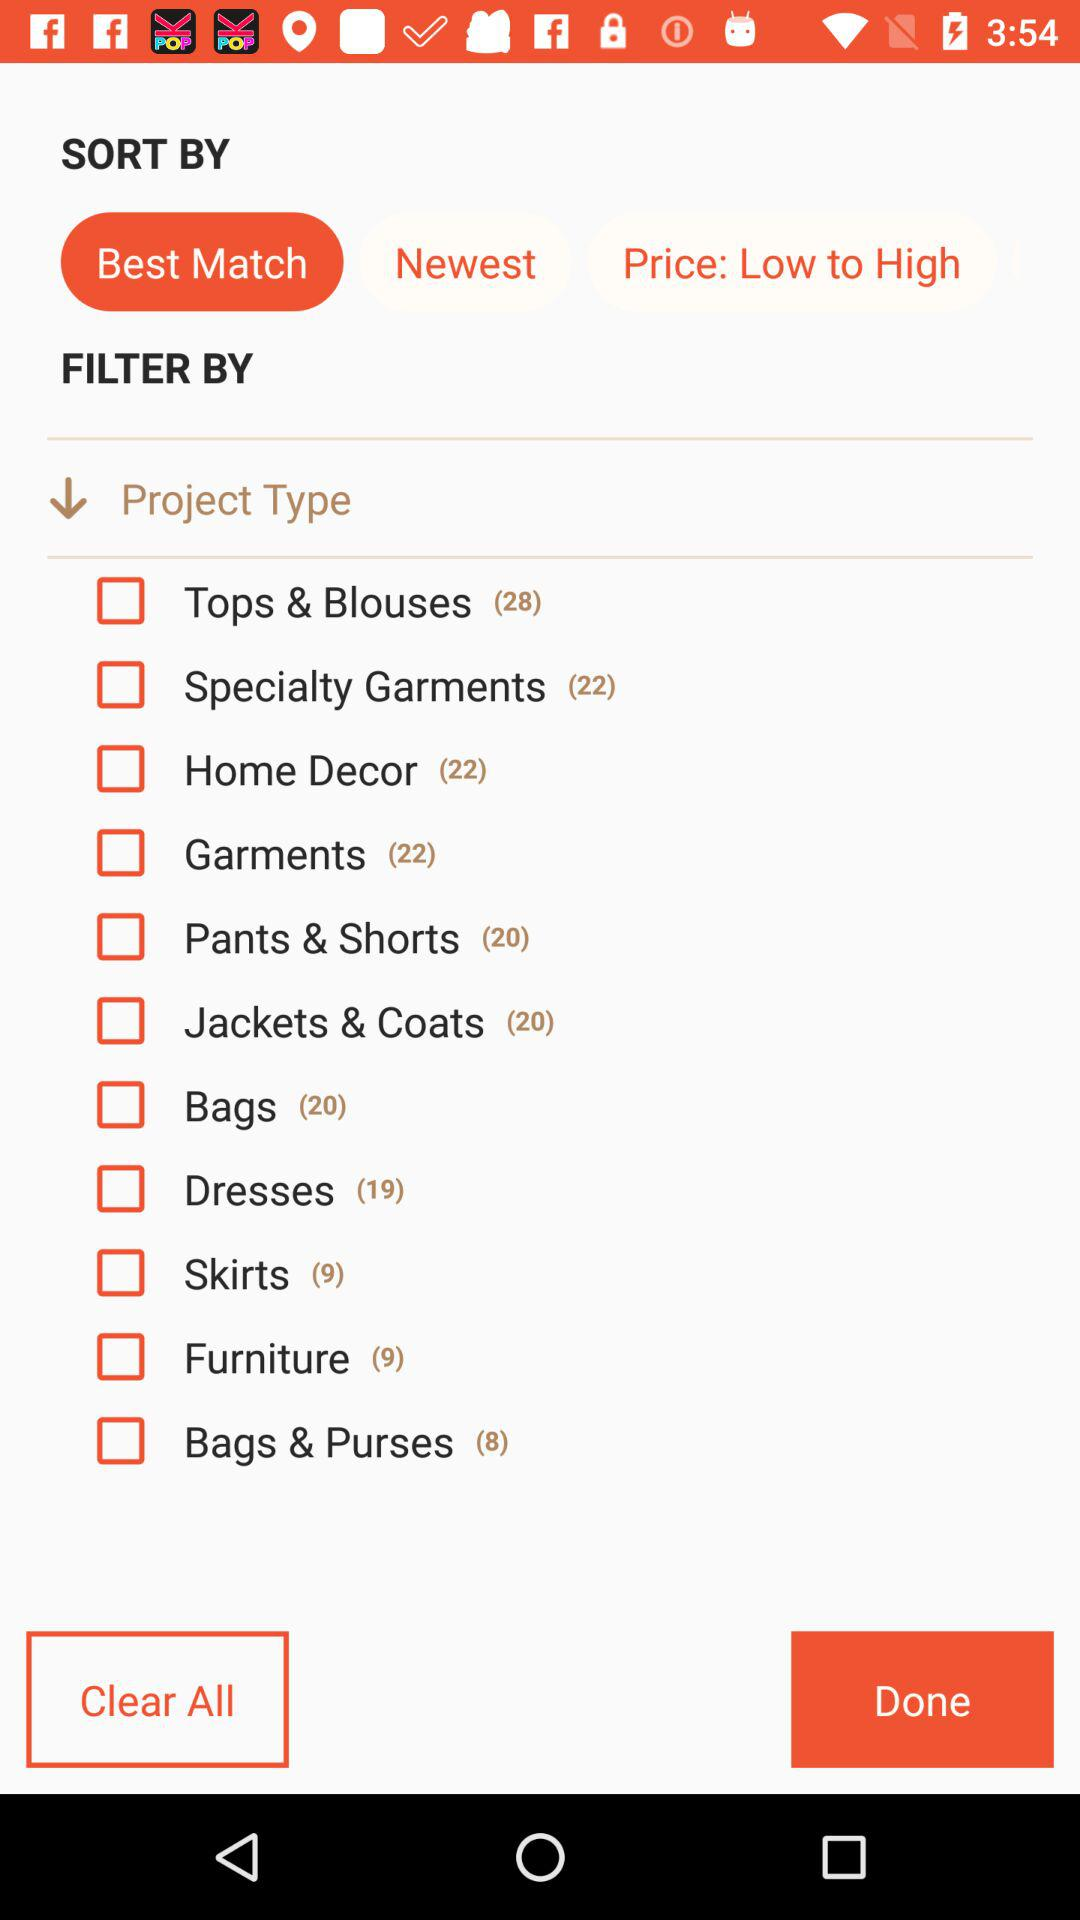How many varieties of garments are there? There are 22 varieties of garments. 